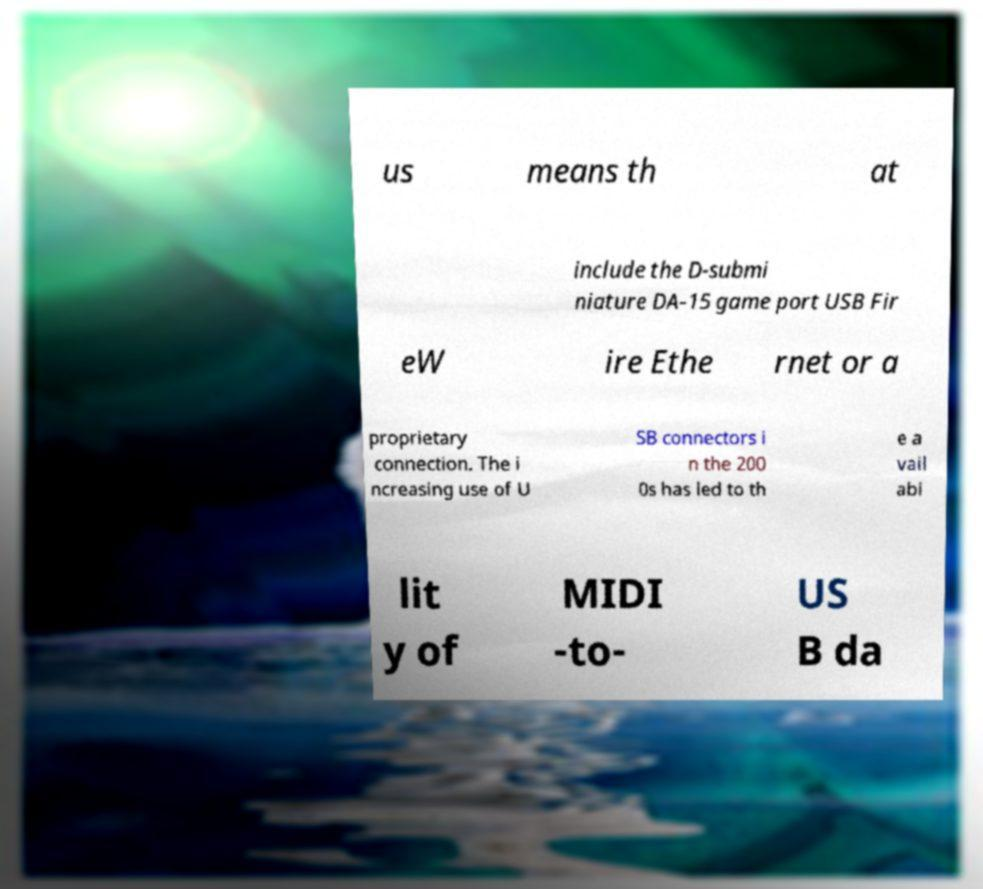Could you extract and type out the text from this image? us means th at include the D-submi niature DA-15 game port USB Fir eW ire Ethe rnet or a proprietary connection. The i ncreasing use of U SB connectors i n the 200 0s has led to th e a vail abi lit y of MIDI -to- US B da 